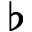<formula> <loc_0><loc_0><loc_500><loc_500>\flat</formula> 